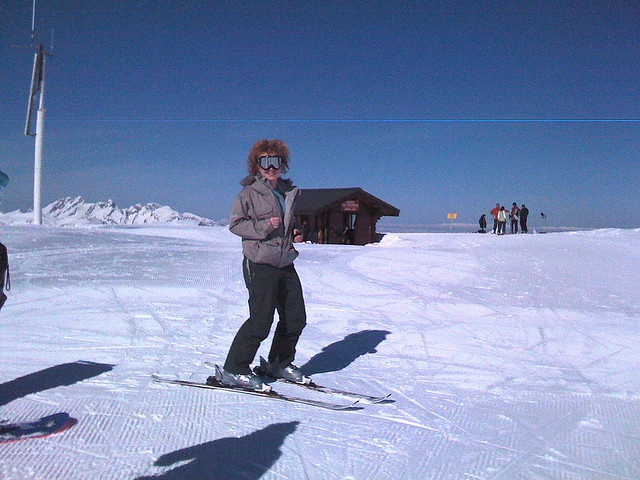Describe the objects in this image and their specific colors. I can see people in navy, black, and gray tones, skis in navy, lavender, darkgray, and gray tones, people in navy, black, and gray tones, people in navy, gray, black, maroon, and darkgray tones, and people in navy, black, darkgray, and gray tones in this image. 